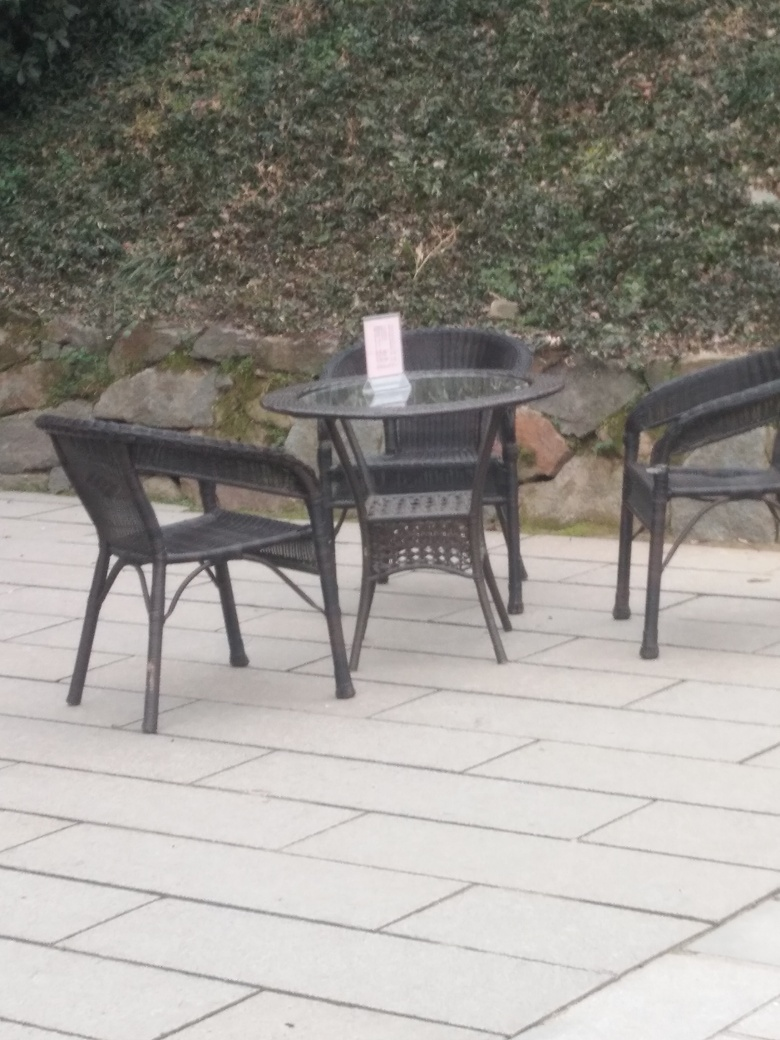Is the chair and table arrangement inviting for guests? The arrangement is practical yet sparse. The chairs are positioned around the table, indicating readiness for use. However, there are no additional decorative elements or settings like tablecloths or place settings that could make the setup more inviting. 